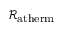<formula> <loc_0><loc_0><loc_500><loc_500>\mathcal { R } _ { a t h e r m }</formula> 